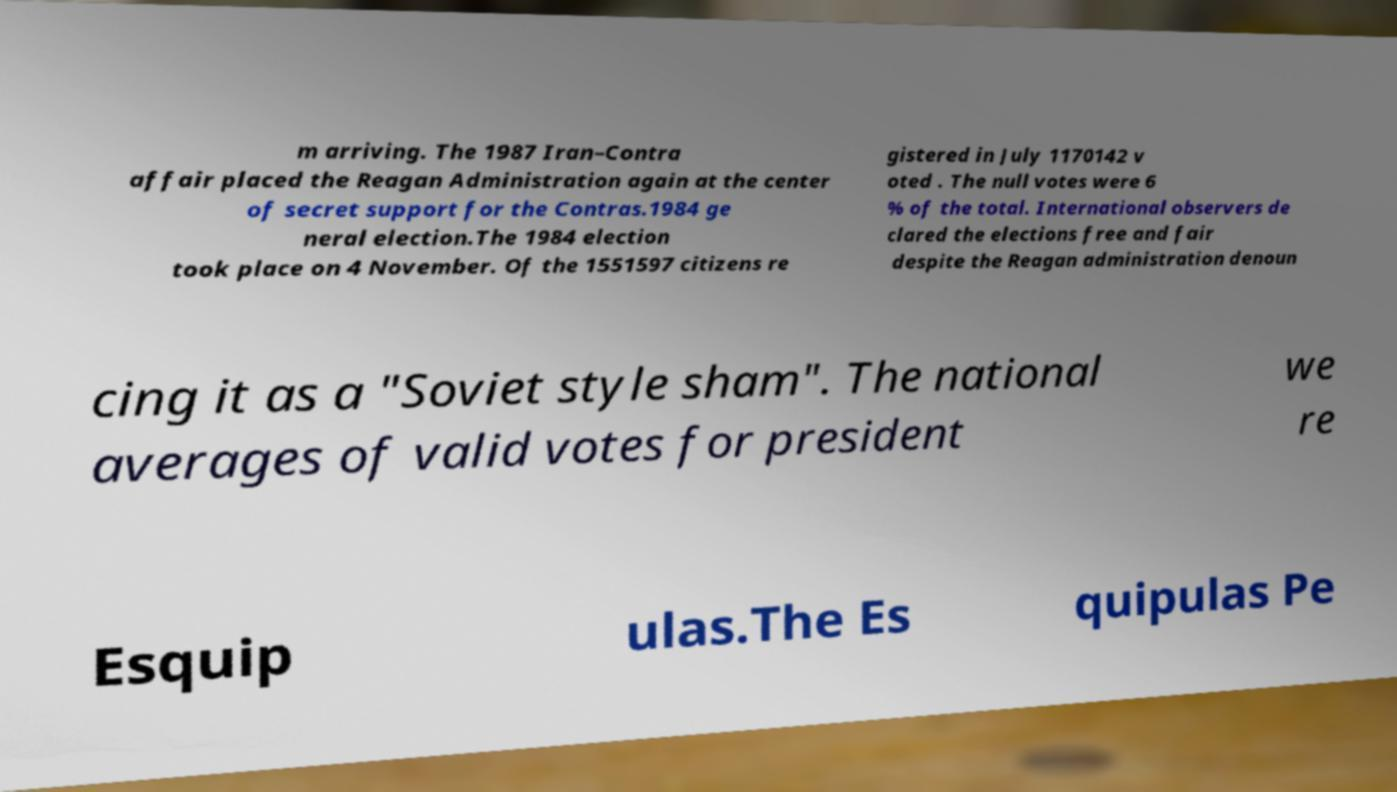Please identify and transcribe the text found in this image. m arriving. The 1987 Iran–Contra affair placed the Reagan Administration again at the center of secret support for the Contras.1984 ge neral election.The 1984 election took place on 4 November. Of the 1551597 citizens re gistered in July 1170142 v oted . The null votes were 6 % of the total. International observers de clared the elections free and fair despite the Reagan administration denoun cing it as a "Soviet style sham". The national averages of valid votes for president we re Esquip ulas.The Es quipulas Pe 